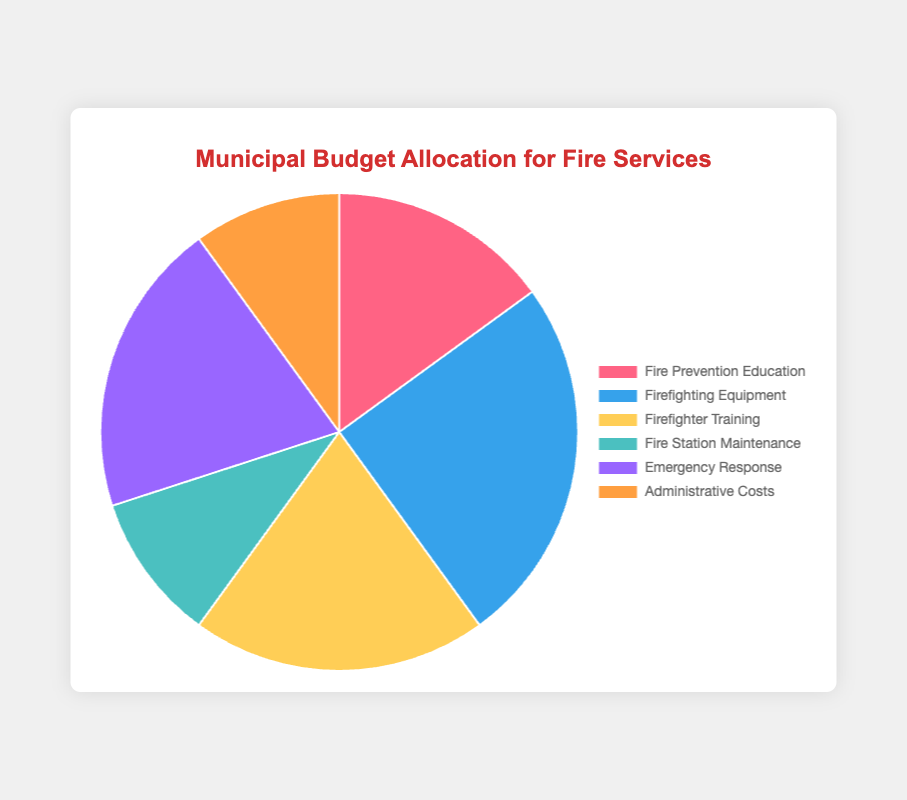Which budget item receives the largest allocation? The figure shows that 'Firefighting Equipment' has the highest percentage allocation, which is 25%.
Answer: Firefighting Equipment What is the combined percentage for 'Emergency Response' and 'Firefighter Training'? To find the combined percentage, add the percentages for 'Emergency Response' (20%) and 'Firefighter Training' (20%): 20% + 20% = 40%.
Answer: 40% How much more is allocated to 'Fire Prevention Education' than 'Fire Station Maintenance'? The percentage for 'Fire Prevention Education' is 15% and for 'Fire Station Maintenance' is 10%. The difference is 15% - 10% = 5%.
Answer: 5% Which two budget items together represent the smallest allocation? To find the two smallest allocations, identify 'Fire Station Maintenance' and 'Administrative Costs', each at 10%. Their combined allocation is 10% + 10% = 20%.
Answer: Fire Station Maintenance and Administrative Costs How does the allocation for 'Administrative Costs' compare to that for 'Emergency Response'? 'Administrative Costs' is 10%, and 'Emergency Response' is 20%. The allocation for 'Emergency Response' is twice that for 'Administrative Costs'.
Answer: Emergency Response is twice as much as Administrative Costs What is the proportion of firefighting-related allocations (i.e., 'Firefighting Equipment' and 'Firefighter Training') to the total budget? Combine 'Firefighting Equipment' (25%) and 'Firefighter Training' (20%): 25% + 20% = 45%.
Answer: 45% What fraction of the budget is allocated to 'Fire Station Maintenance' relative to 'Fire Prevention Education'? 'Fire Station Maintenance' is 10%, and 'Fire Prevention Education' is 15%. The fraction is calculated as 10% / 15%, which simplifies to 2/3.
Answer: 2/3 What visual attribute represents 'Emergency Response'? The 'Emergency Response' segment is represented by the purple color in the pie chart.
Answer: Purple If the budget for 'Administrative Costs' is doubled, what would be the new percentage? The initial percentage for 'Administrative Costs' is 10%. Doubling it results in 10% * 2 = 20%.
Answer: 20% Which has a greater allocation, 'Firefighter Training' or 'Fire Station Maintenance'? How much greater? 'Firefighter Training' is allocated 20% and 'Fire Station Maintenance' is allocated 10%. The difference is 20% - 10% = 10%.
Answer: Firefighter Training by 10% 